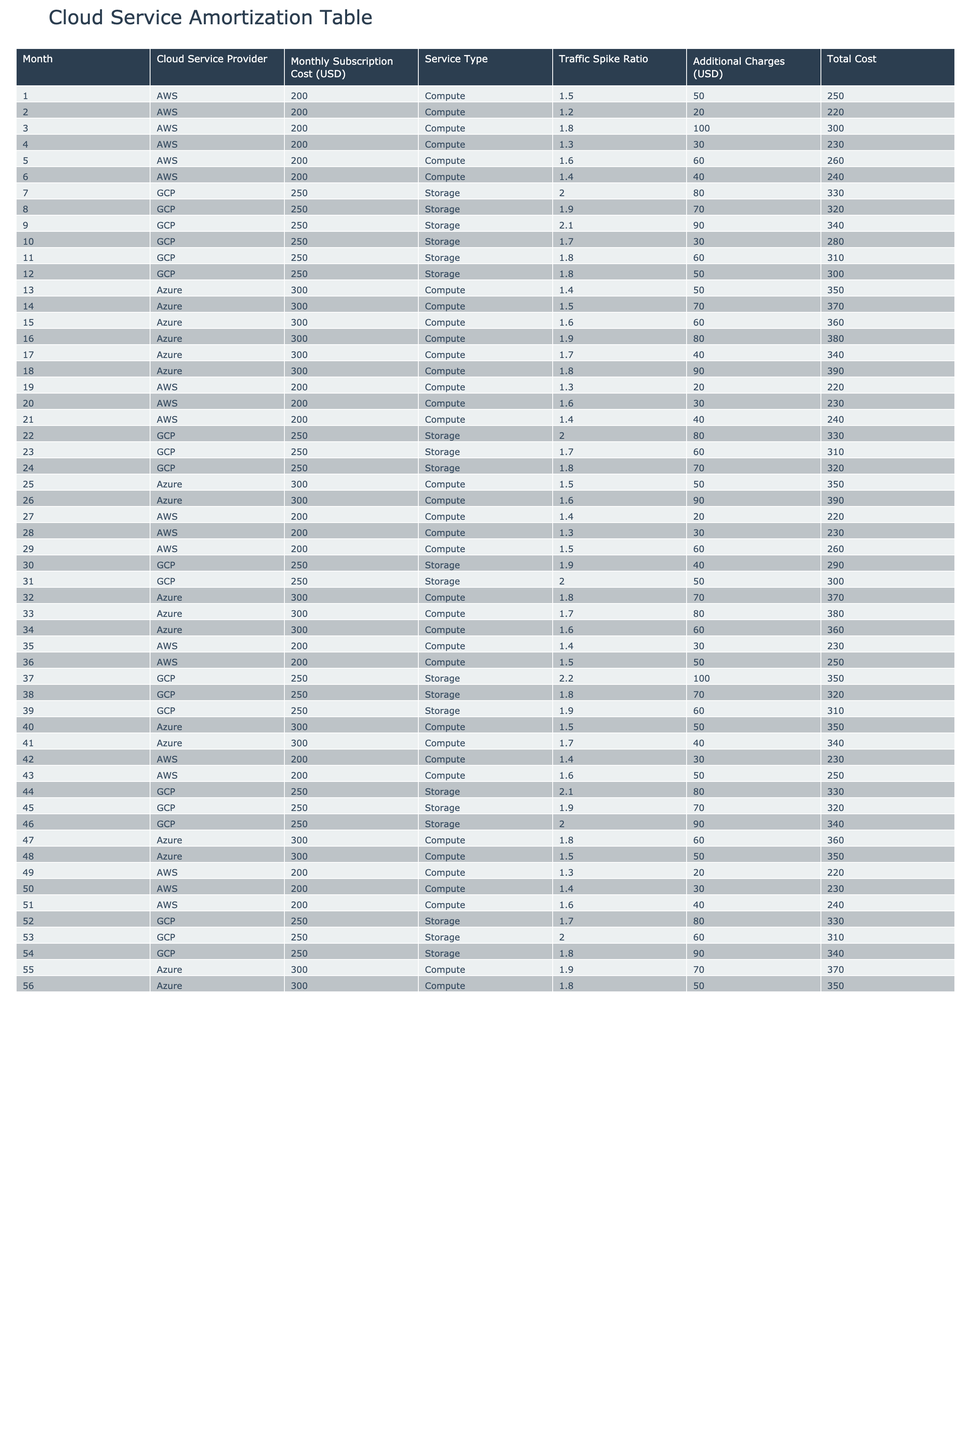What is the monthly subscription cost for GCP in the first month? The table indicates that in month 7, GCP has a monthly subscription cost of 250 USD for storage services. Since month 7 corresponds to the first month of GCP, that is the amount shown.
Answer: 250 USD What additional charges did AWS incur in month 5? Looking at the table, in month 5 for AWS, the additional charges listed are 60 USD alongside the monthly subscription cost of 200 USD.
Answer: 60 USD What is the total cost for Azure in month 16? For Azure in month 16, the monthly subscription cost is 300 USD and additional charges are 80 USD. The total cost is calculated by adding both: 300 + 80 = 380 USD.
Answer: 380 USD Which provider had the highest additional charges in month 39? In month 39, the table shows that GCP had additional charges of 60 USD, while AWS had 30 USD, and Azure had 50 USD. GCP had the highest additional charges in that month.
Answer: GCP What is the average monthly subscription cost for AWS over the first 12 months? The monthly subscription cost for AWS in the first 12 months is consistently 200 USD. To find the average, sum the monthly costs (200 * 12) and divide by 12, which is 200. Thus, the average is 200 USD.
Answer: 200 USD Was the total cost for GCP ever greater than 350 USD in any month? Checking the total costs for GCP, we find the maximum monthly total (monthly subscription cost + additional charges) is 340 USD in month 39 (250 + 90). Therefore, it was never greater than 350 USD.
Answer: No Calculate the total additional charges for Azure over the first 12 months. Summing the additional charges for Azure over the first 12 months, we get: 50 + 70 + 60 + 80 + 40 + 90 + 50 + 60 = 400 USD. Thus, the total additional charges amount to 400 USD.
Answer: 400 USD In which month did GCP have the lowest additional charges? By reviewing the table, GCP's lowest additional charges occurred in month 10 with only 30 USD. This assessment is based on the comparison of all additional charges throughout the months listed.
Answer: Month 10 